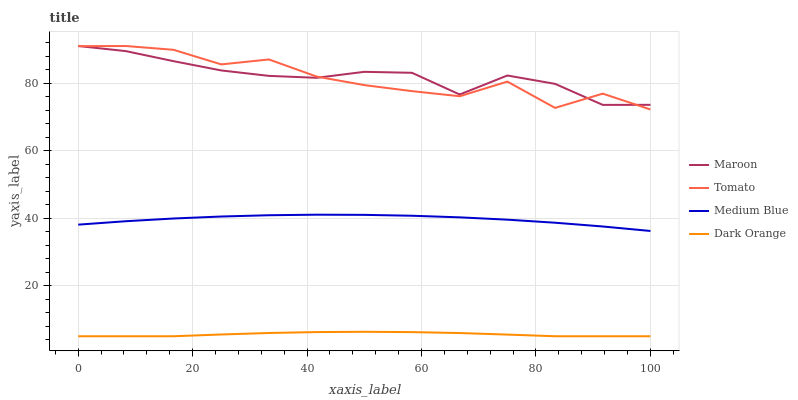Does Medium Blue have the minimum area under the curve?
Answer yes or no. No. Does Medium Blue have the maximum area under the curve?
Answer yes or no. No. Is Medium Blue the smoothest?
Answer yes or no. No. Is Medium Blue the roughest?
Answer yes or no. No. Does Medium Blue have the lowest value?
Answer yes or no. No. Does Medium Blue have the highest value?
Answer yes or no. No. Is Medium Blue less than Tomato?
Answer yes or no. Yes. Is Maroon greater than Medium Blue?
Answer yes or no. Yes. Does Medium Blue intersect Tomato?
Answer yes or no. No. 